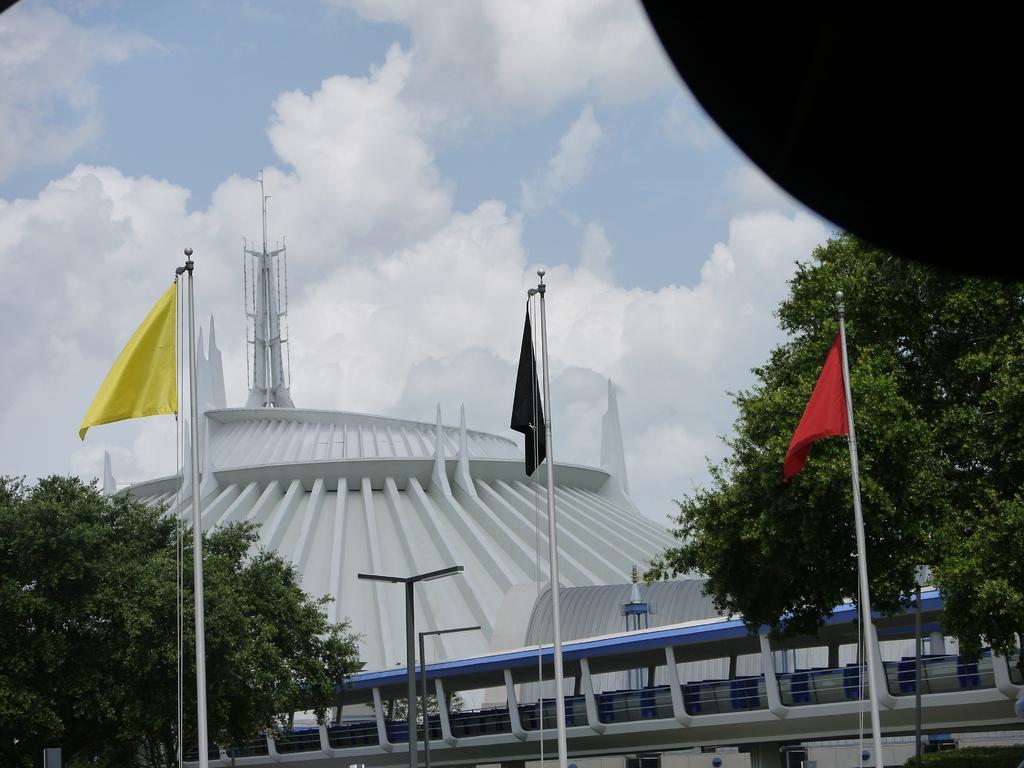How would you summarize this image in a sentence or two? In t he center of the image there are flags and flagpoles. There are trees. In the background of the image there is a building. There is a tower. At the top of the image there is sky and clouds. 